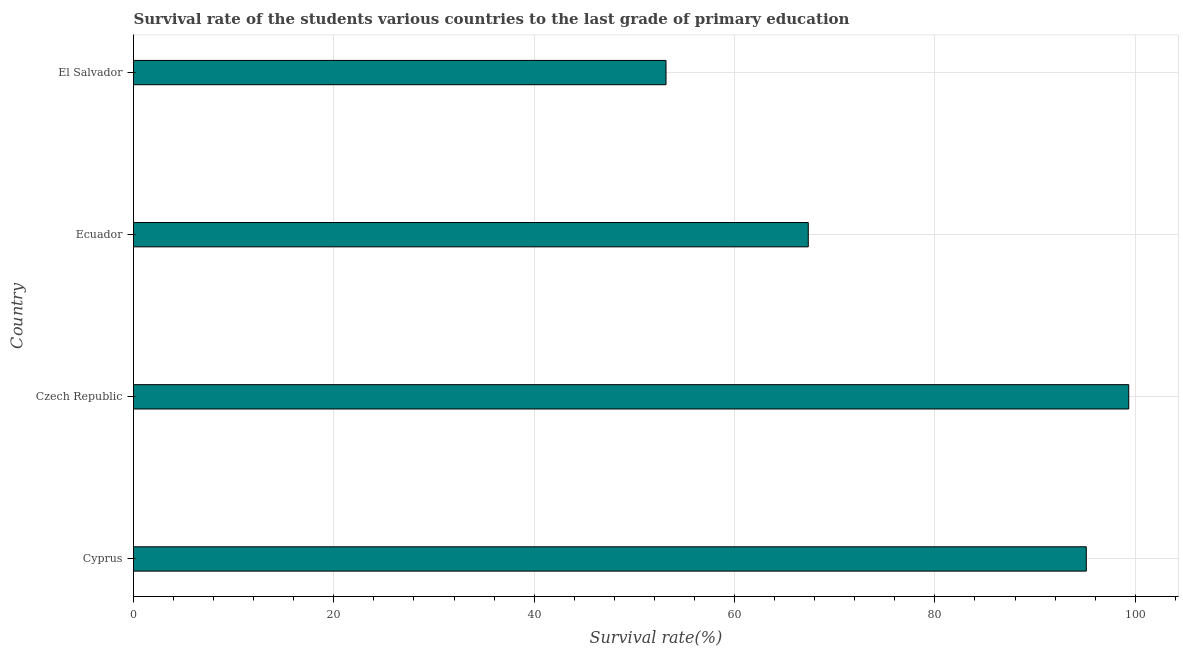Does the graph contain any zero values?
Make the answer very short. No. What is the title of the graph?
Ensure brevity in your answer.  Survival rate of the students various countries to the last grade of primary education. What is the label or title of the X-axis?
Keep it short and to the point. Survival rate(%). What is the survival rate in primary education in Cyprus?
Provide a succinct answer. 95.12. Across all countries, what is the maximum survival rate in primary education?
Ensure brevity in your answer.  99.35. Across all countries, what is the minimum survival rate in primary education?
Provide a short and direct response. 53.16. In which country was the survival rate in primary education maximum?
Give a very brief answer. Czech Republic. In which country was the survival rate in primary education minimum?
Make the answer very short. El Salvador. What is the sum of the survival rate in primary education?
Make the answer very short. 315. What is the difference between the survival rate in primary education in Cyprus and Czech Republic?
Your answer should be compact. -4.24. What is the average survival rate in primary education per country?
Provide a short and direct response. 78.75. What is the median survival rate in primary education?
Give a very brief answer. 81.24. Is the survival rate in primary education in Ecuador less than that in El Salvador?
Offer a very short reply. No. What is the difference between the highest and the second highest survival rate in primary education?
Your answer should be compact. 4.24. What is the difference between the highest and the lowest survival rate in primary education?
Keep it short and to the point. 46.19. In how many countries, is the survival rate in primary education greater than the average survival rate in primary education taken over all countries?
Provide a succinct answer. 2. How many bars are there?
Give a very brief answer. 4. What is the difference between two consecutive major ticks on the X-axis?
Provide a succinct answer. 20. What is the Survival rate(%) in Cyprus?
Keep it short and to the point. 95.12. What is the Survival rate(%) of Czech Republic?
Provide a short and direct response. 99.35. What is the Survival rate(%) of Ecuador?
Your answer should be very brief. 67.36. What is the Survival rate(%) in El Salvador?
Ensure brevity in your answer.  53.16. What is the difference between the Survival rate(%) in Cyprus and Czech Republic?
Offer a very short reply. -4.24. What is the difference between the Survival rate(%) in Cyprus and Ecuador?
Offer a terse response. 27.76. What is the difference between the Survival rate(%) in Cyprus and El Salvador?
Ensure brevity in your answer.  41.96. What is the difference between the Survival rate(%) in Czech Republic and Ecuador?
Make the answer very short. 31.99. What is the difference between the Survival rate(%) in Czech Republic and El Salvador?
Provide a short and direct response. 46.19. What is the difference between the Survival rate(%) in Ecuador and El Salvador?
Offer a terse response. 14.2. What is the ratio of the Survival rate(%) in Cyprus to that in Ecuador?
Make the answer very short. 1.41. What is the ratio of the Survival rate(%) in Cyprus to that in El Salvador?
Ensure brevity in your answer.  1.79. What is the ratio of the Survival rate(%) in Czech Republic to that in Ecuador?
Make the answer very short. 1.48. What is the ratio of the Survival rate(%) in Czech Republic to that in El Salvador?
Make the answer very short. 1.87. What is the ratio of the Survival rate(%) in Ecuador to that in El Salvador?
Keep it short and to the point. 1.27. 